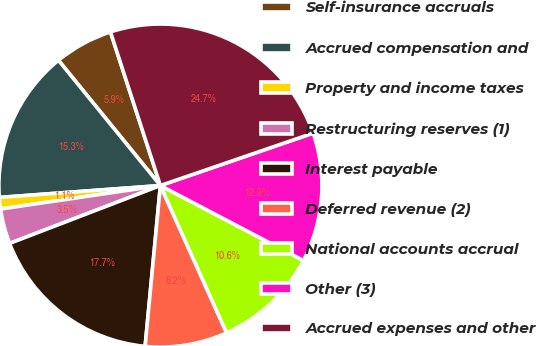<chart> <loc_0><loc_0><loc_500><loc_500><pie_chart><fcel>Self-insurance accruals<fcel>Accrued compensation and<fcel>Property and income taxes<fcel>Restructuring reserves (1)<fcel>Interest payable<fcel>Deferred revenue (2)<fcel>National accounts accrual<fcel>Other (3)<fcel>Accrued expenses and other<nl><fcel>5.87%<fcel>15.3%<fcel>1.15%<fcel>3.51%<fcel>17.66%<fcel>8.23%<fcel>10.59%<fcel>12.95%<fcel>24.74%<nl></chart> 